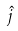Convert formula to latex. <formula><loc_0><loc_0><loc_500><loc_500>\hat { j }</formula> 